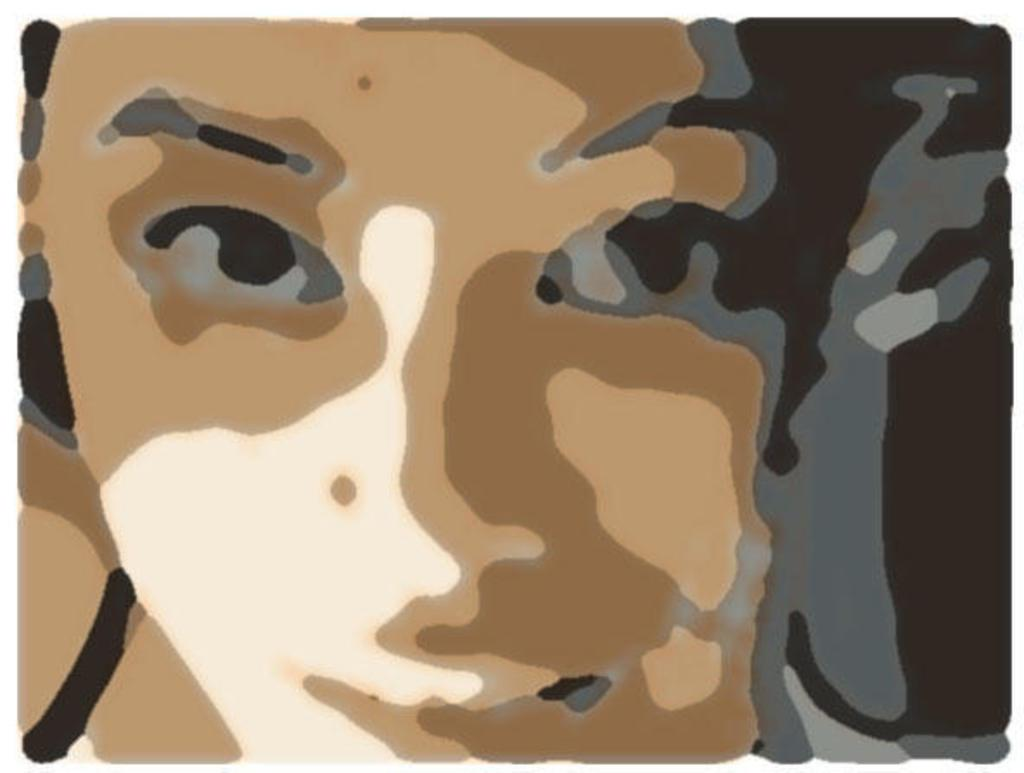What is the main subject of the image? The main subject of the image is a painting. What does the painting depict? The painting depicts a woman's face. What time of day is it in the image? The time of day is not mentioned or depicted in the image, as it only features a painting of a woman's face. How long does it take for the woman's face to change expression in the painting? The painting is a static image, so the woman's face does not change expression, and therefore it is not possible to measure the time it takes for such a change. 